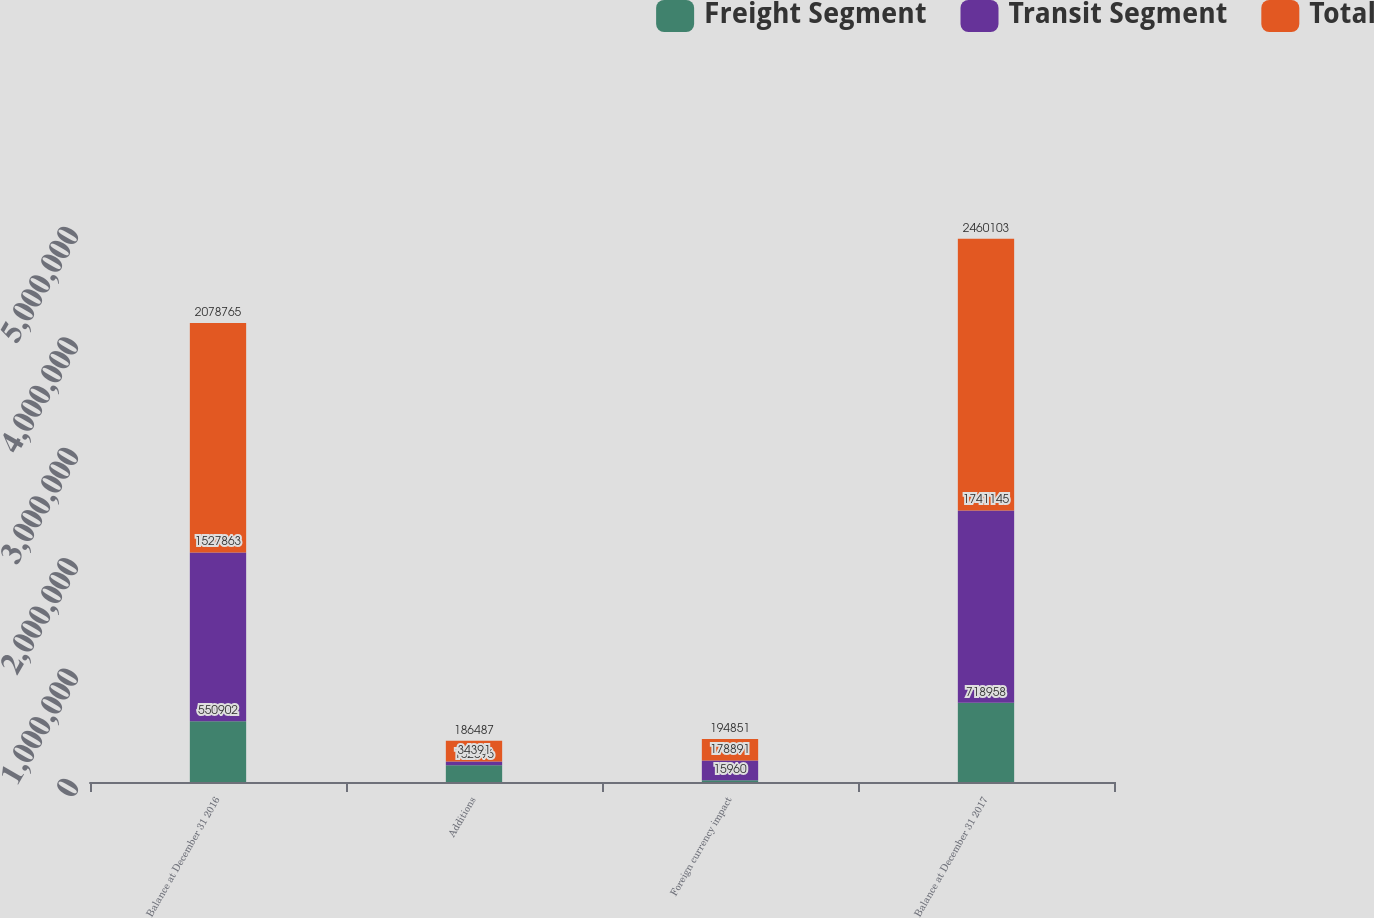<chart> <loc_0><loc_0><loc_500><loc_500><stacked_bar_chart><ecel><fcel>Balance at December 31 2016<fcel>Additions<fcel>Foreign currency impact<fcel>Balance at December 31 2017<nl><fcel>Freight Segment<fcel>550902<fcel>152096<fcel>15960<fcel>718958<nl><fcel>Transit Segment<fcel>1.52786e+06<fcel>34391<fcel>178891<fcel>1.74114e+06<nl><fcel>Total<fcel>2.07876e+06<fcel>186487<fcel>194851<fcel>2.4601e+06<nl></chart> 